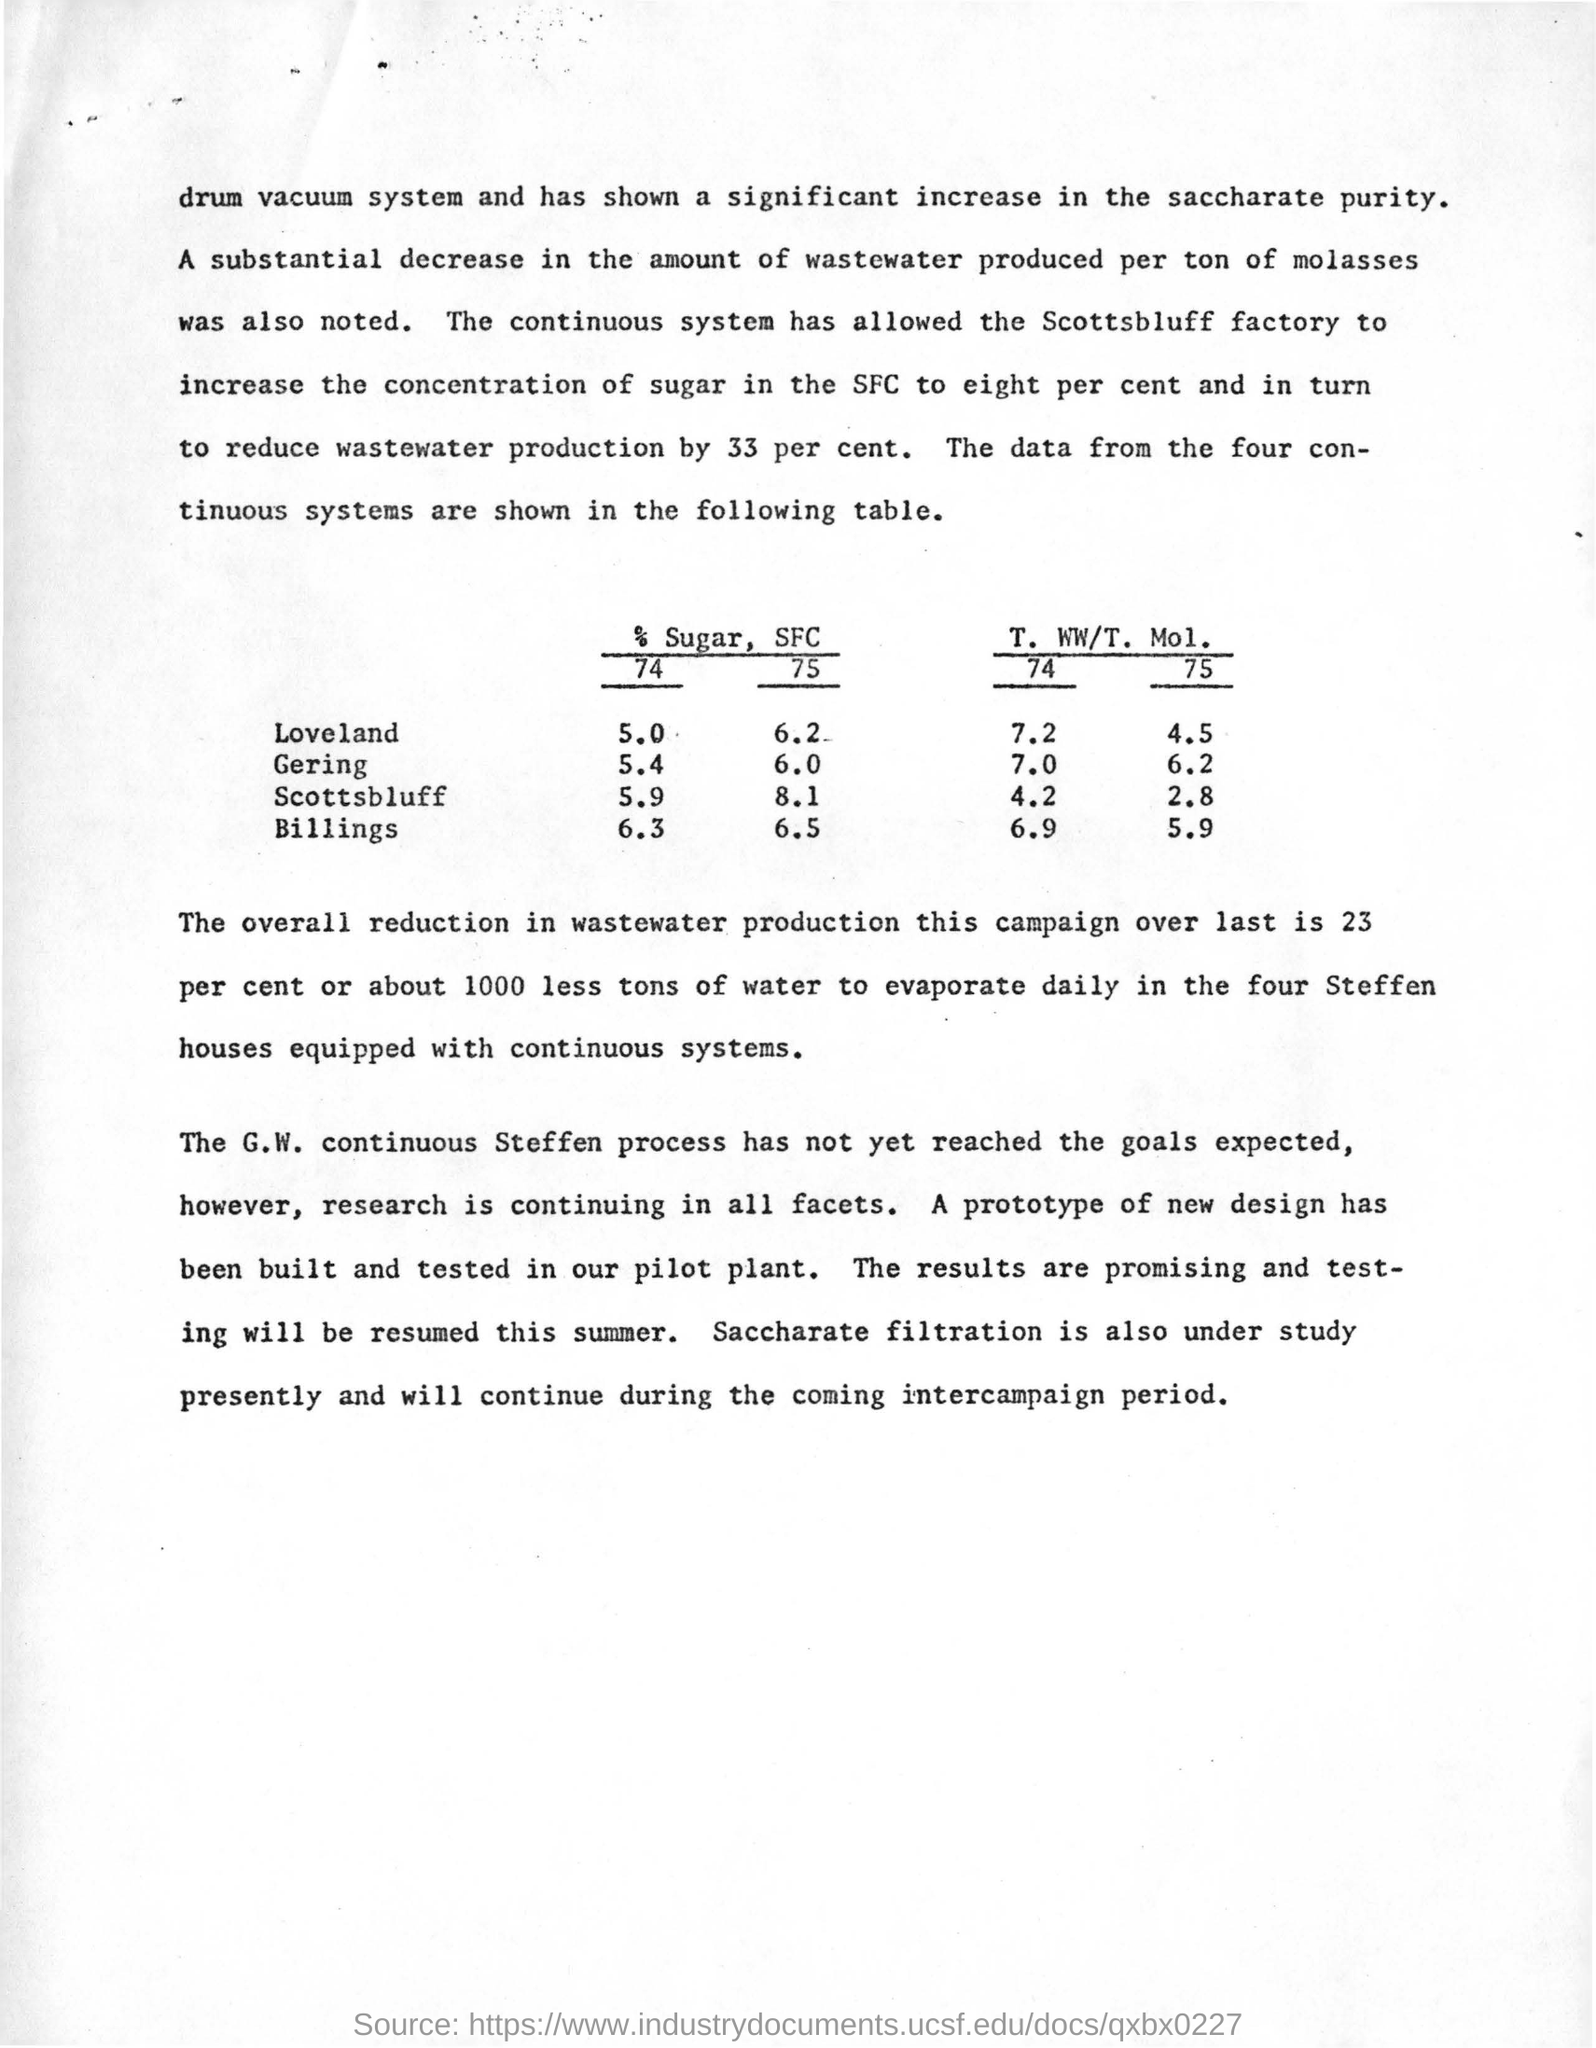Which system has  shown a significant increase in the saccharate purity?
Keep it short and to the point. Drum vacuum system. Which filtration is under study presently?
Offer a very short reply. Saccharate filtration. What data is shown in the table given?
Your answer should be compact. The data from the four continuous systems are shown in the following table. Which continuous process has not reached the expected goals?
Give a very brief answer. The G.W. continuous Steffen Process. When will be the testing of new design resumed?
Your answer should be very brief. The testing will be resumed this summer. 